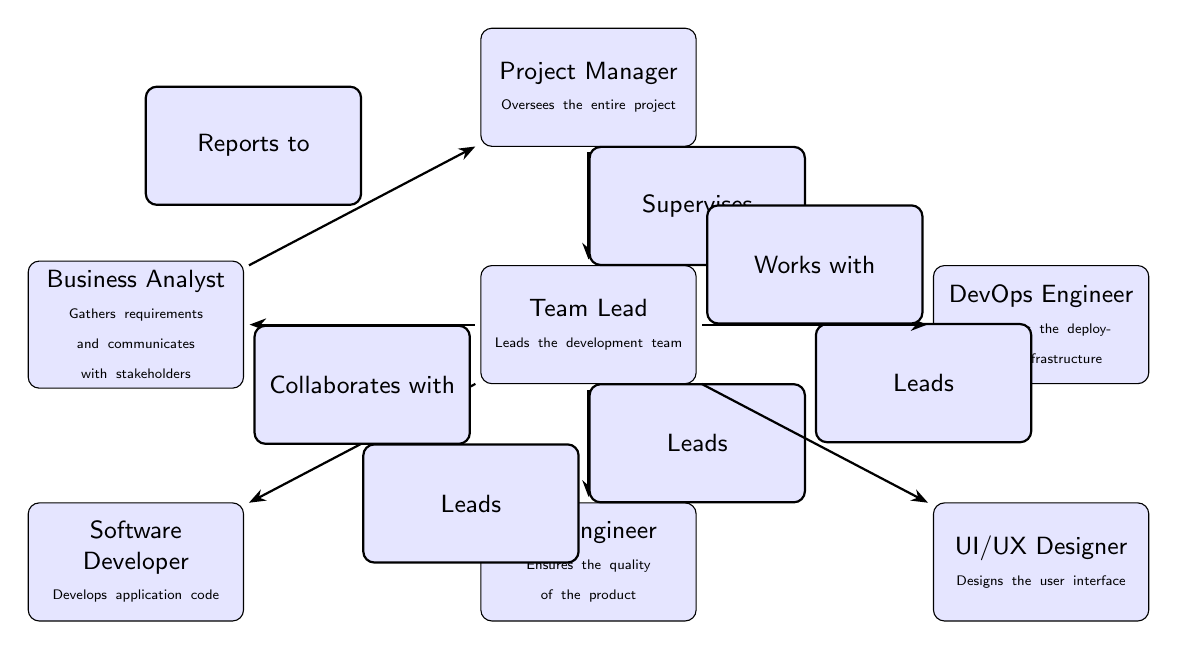What is the role of the person at the top of the chart? The top node in the chart represents the Project Manager. The description states that this role oversees the entire project, indicating that they hold a leadership position responsible for the overall project management.
Answer: Project Manager How many team members report directly to the Team Lead? The Team Lead in the diagram has three team members (Software Developer, QA Engineer, and UI/UX Designer) directly reporting to them as indicated by the edges that originate from the Team Lead node to these roles.
Answer: 3 Who collaborates with the Team Lead? The diagram indicates that the Business Analyst collaborates with the Team Lead, as shown by the edge labeled "Collaborates with" leading from the Team Lead to the Business Analyst node.
Answer: Business Analyst Which role is responsible for maintaining the deployment infrastructure? The role responsible for maintaining the deployment infrastructure is the DevOps Engineer, as specified in the node description. The DevOps Engineer is connected to the Team Lead by an edge titled "Works with," indicating this relationship.
Answer: DevOps Engineer How many total nodes are present in the diagram? The diagram includes a total of six distinct roles represented as nodes: Project Manager, Team Lead, Software Developer, QA Engineer, UI/UX Designer, Business Analyst, and DevOps Engineer. Counting them gives a total of seven nodes.
Answer: 7 What is the primary responsibility of the QA Engineer? The primary responsibility of the QA Engineer, as described in the node, is to ensure the quality of the product. This indicates their role within the project team concerning product quality assurance.
Answer: Ensures the quality of the product Which role does the Business Analyst report to? The diagram specifies that the Business Analyst reports to the Project Manager, as indicated by the edge titled "Reports to," connecting the Business Analyst node to the Project Manager node.
Answer: Project Manager What is the relationship between the Team Lead and the Software Developer? The Team Lead leads the Software Developer, denoted by the edge labeled "Leads" that connects the Team Lead to the Software Developer. This indicates that the Team Lead is in a supervisory role over the Software Developer.
Answer: Leads How does the DevOps Engineer interact with the Team Lead? The interaction between the DevOps Engineer and the Team Lead is specified as "Works with," as shown by the edge connecting these two roles. This suggests a joint effort or cooperation in their work responsibilities.
Answer: Works with 